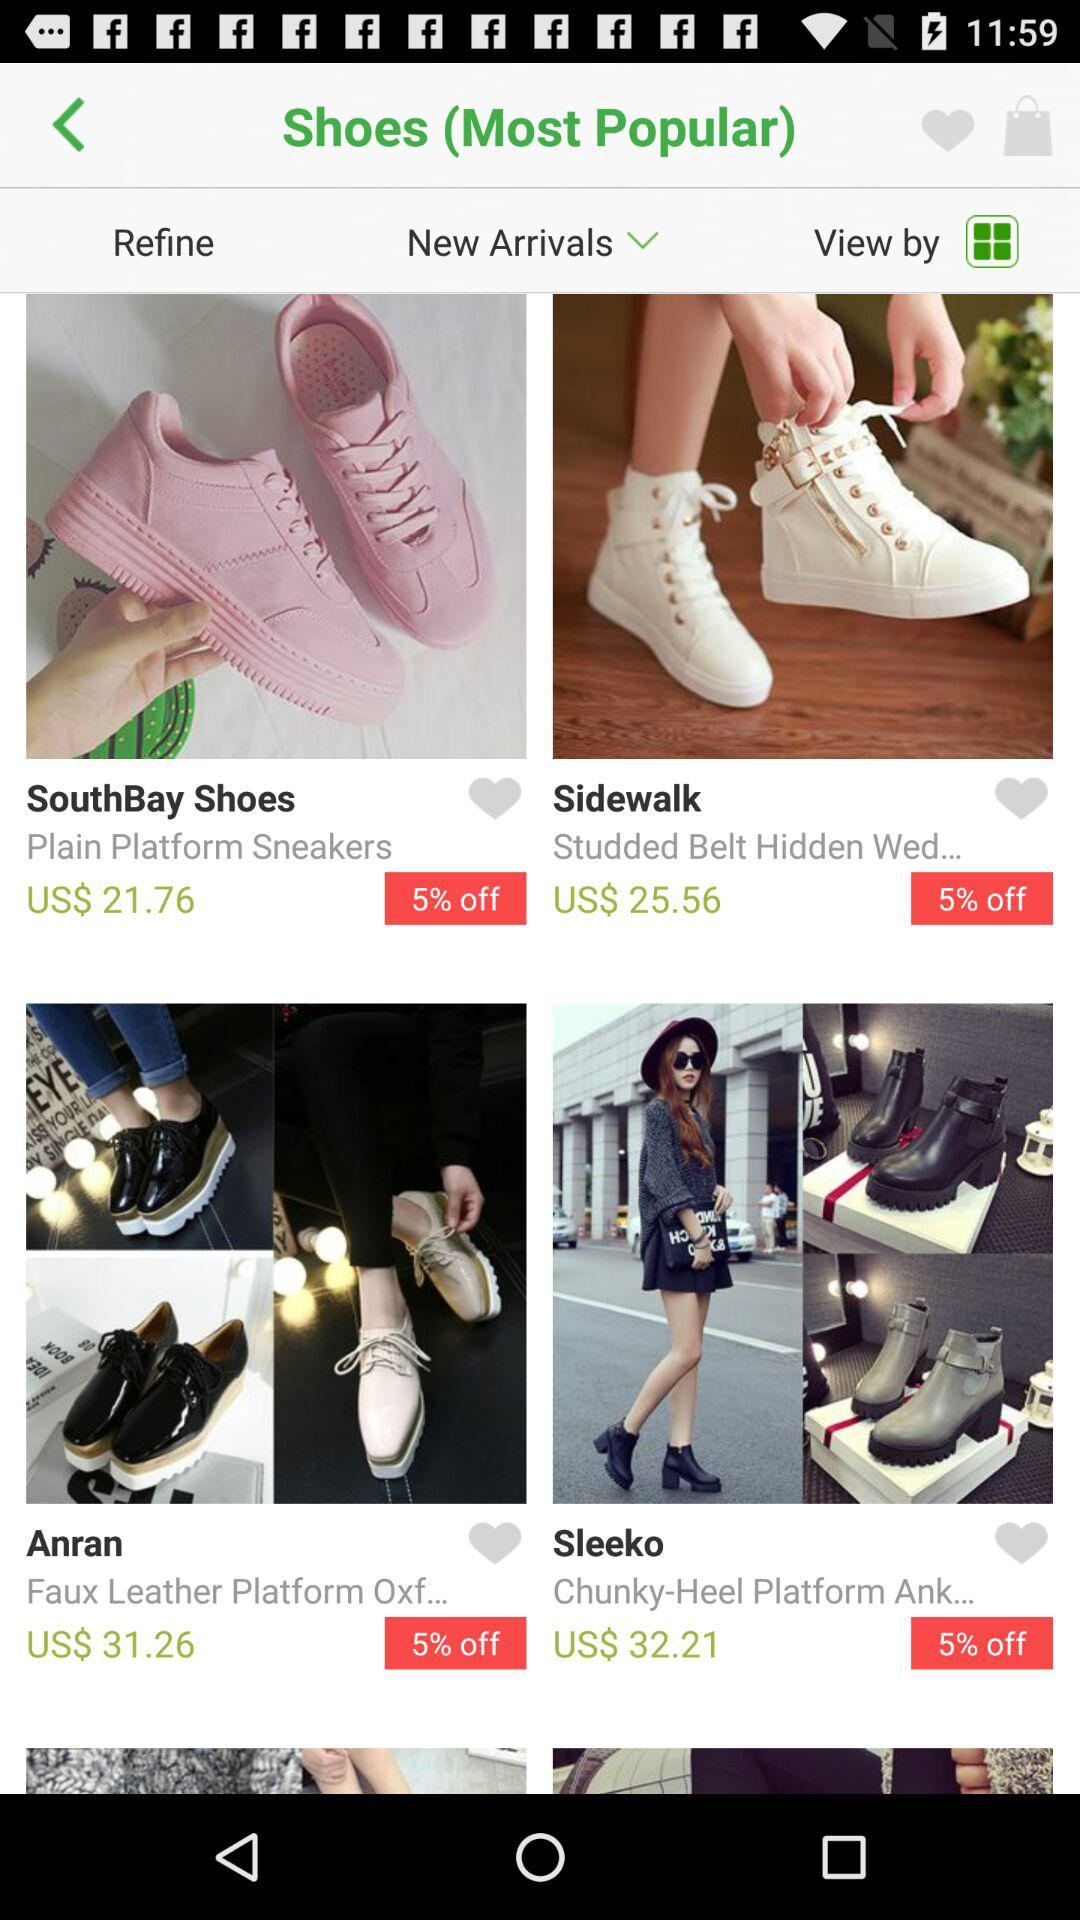What is the name of the brand that has "Plain Platform Sneakers" shoes? The name of the brand that has "Plain Platform Sneakers" shoes is SouthBay Shoes. 